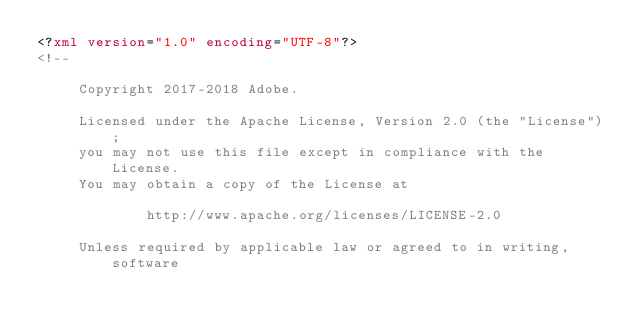<code> <loc_0><loc_0><loc_500><loc_500><_XML_><?xml version="1.0" encoding="UTF-8"?>
<!--

     Copyright 2017-2018 Adobe.

     Licensed under the Apache License, Version 2.0 (the "License");
     you may not use this file except in compliance with the License.
     You may obtain a copy of the License at

             http://www.apache.org/licenses/LICENSE-2.0

     Unless required by applicable law or agreed to in writing, software</code> 